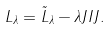Convert formula to latex. <formula><loc_0><loc_0><loc_500><loc_500>L _ { \lambda } = \tilde { L } _ { \lambda } - \lambda J I J .</formula> 